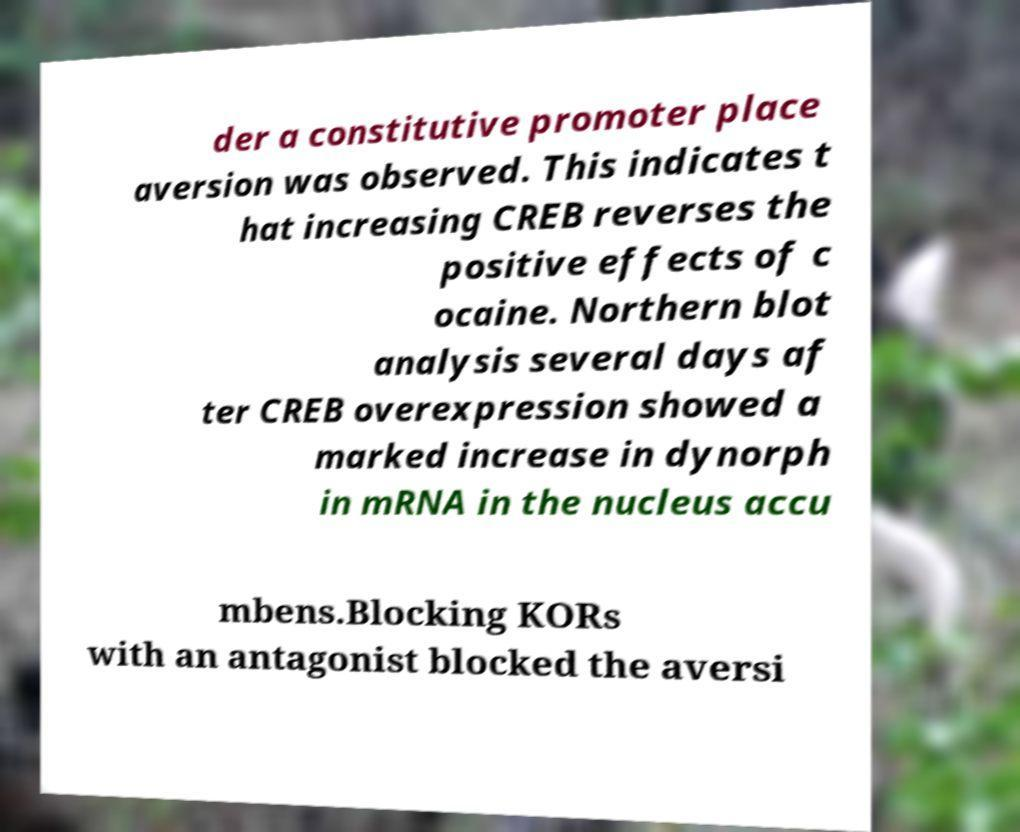What messages or text are displayed in this image? I need them in a readable, typed format. der a constitutive promoter place aversion was observed. This indicates t hat increasing CREB reverses the positive effects of c ocaine. Northern blot analysis several days af ter CREB overexpression showed a marked increase in dynorph in mRNA in the nucleus accu mbens.Blocking KORs with an antagonist blocked the aversi 